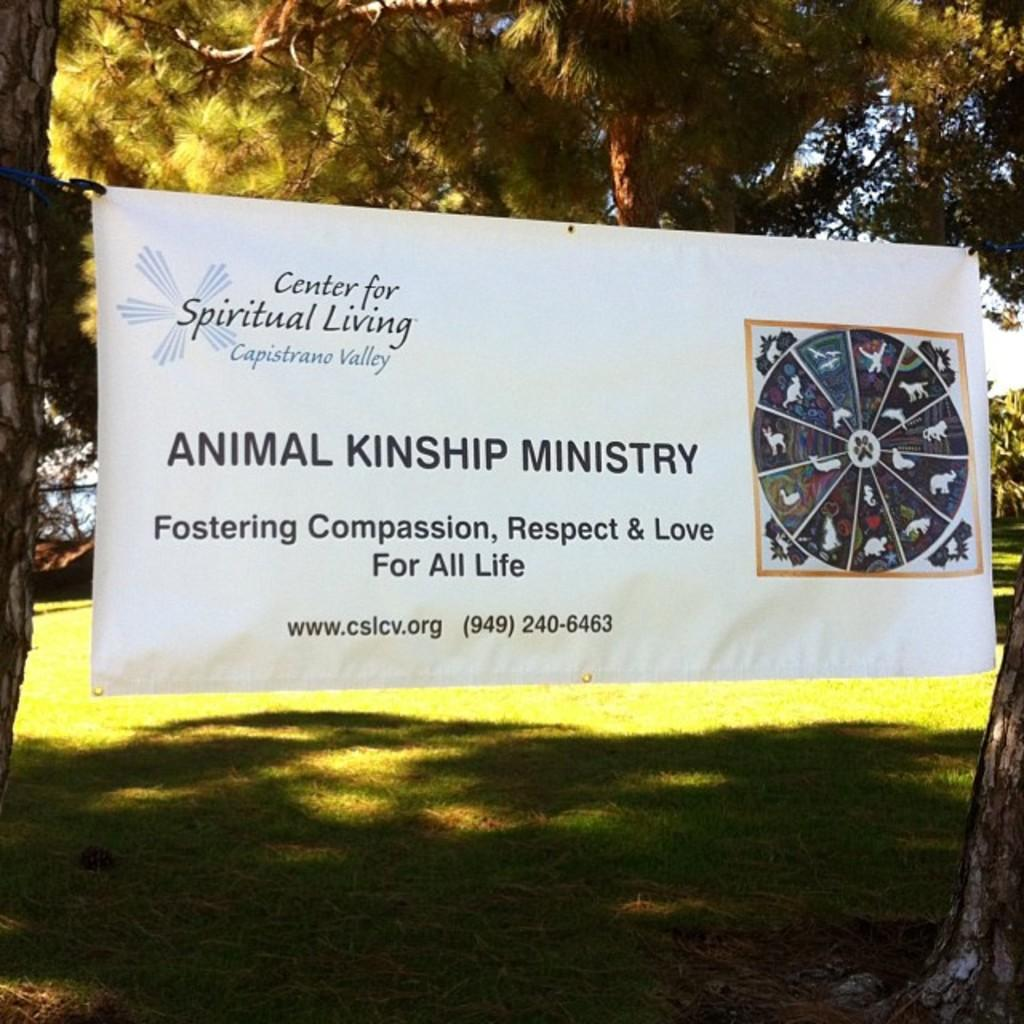What is featured on the banner in the picture? There is a banner with text and an image in the picture. What type of natural environment is depicted in the picture? There are trees and grass in the picture, indicating a natural setting. What can be seen in the sky in the picture? The sky is visible in the picture. What type of soup is being served in the picture? There is no soup present in the picture; it features a banner with text and an image, as well as trees, grass, and the sky. How many dolls can be seen playing in the grass in the picture? There are no dolls present in the picture; it features a banner with text and an image, trees, grass, and the sky. 